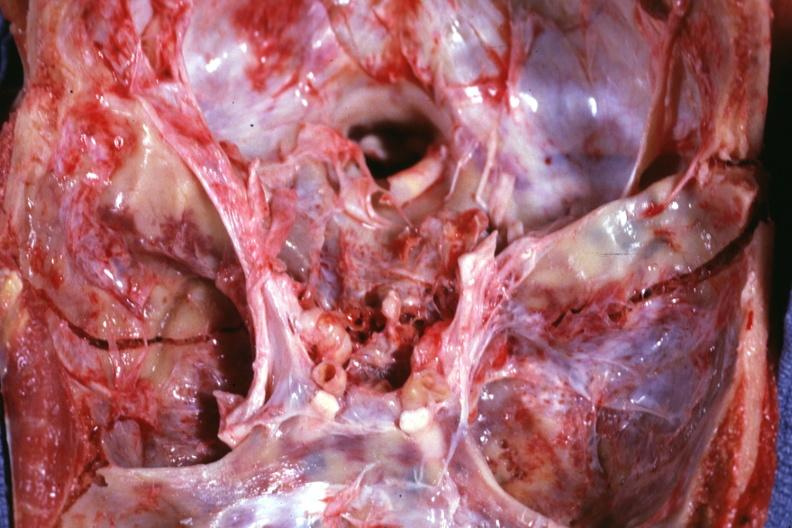does this image show close-up bilateral fractures?
Answer the question using a single word or phrase. Yes 